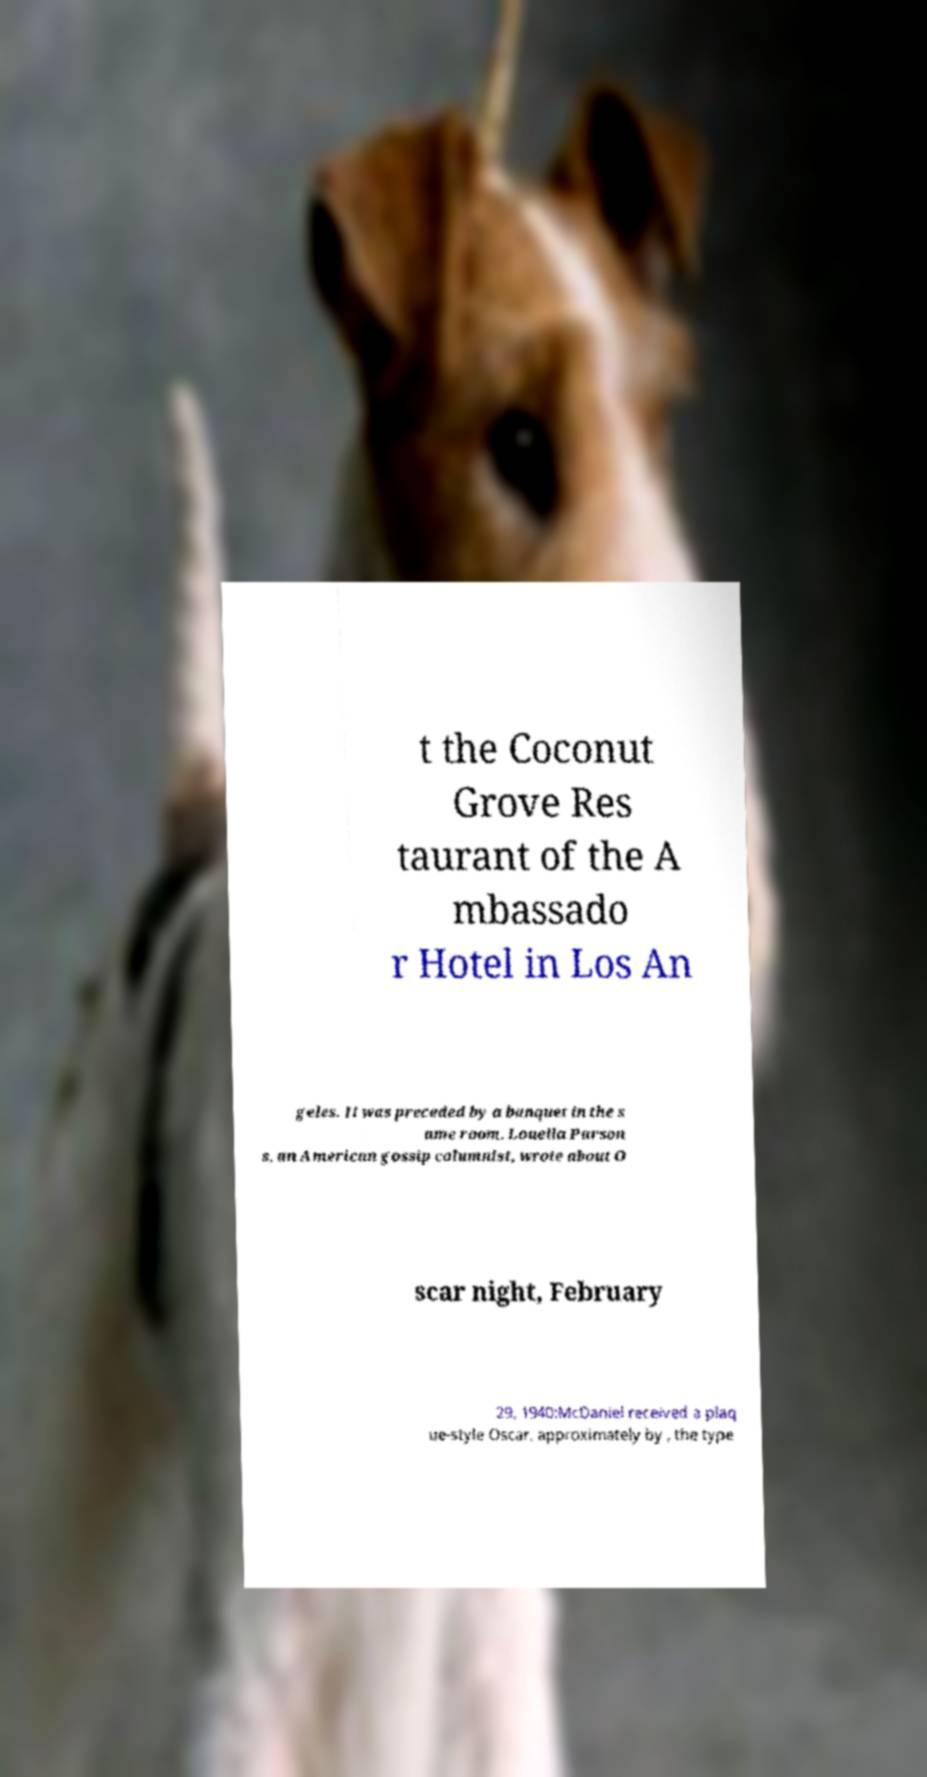Could you assist in decoding the text presented in this image and type it out clearly? t the Coconut Grove Res taurant of the A mbassado r Hotel in Los An geles. It was preceded by a banquet in the s ame room. Louella Parson s, an American gossip columnist, wrote about O scar night, February 29, 1940:McDaniel received a plaq ue-style Oscar, approximately by , the type 